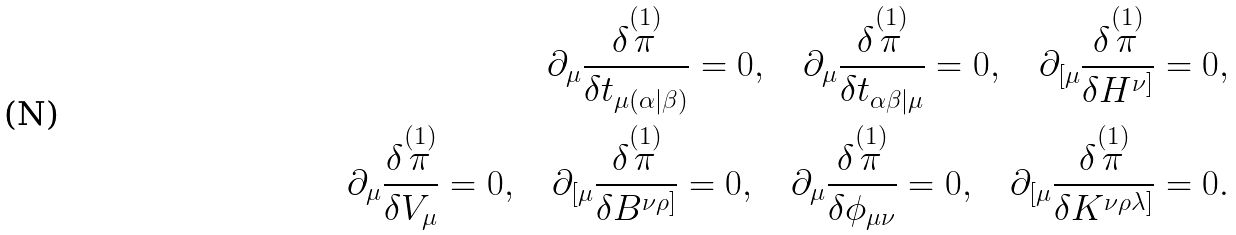<formula> <loc_0><loc_0><loc_500><loc_500>\partial _ { \mu } \frac { \delta \overset { ( 1 ) } { \pi } } { \delta t _ { \mu ( \alpha | \beta ) } } = 0 , \quad \partial _ { \mu } \frac { \delta \overset { ( 1 ) } { \pi } } { \delta t _ { \alpha \beta | \mu } } = 0 , \quad \partial _ { [ \mu } \frac { \delta \overset { ( 1 ) } { \pi } } { \delta H ^ { \nu ] } } = 0 , \\ \partial _ { \mu } \frac { \delta \overset { ( 1 ) } { \pi } } { \delta V _ { \mu } } = 0 , \quad \partial _ { [ \mu } \frac { \delta \overset { ( 1 ) } { \pi } } { \delta B ^ { \nu \rho ] } } = 0 , \quad \partial _ { \mu } \frac { \delta \overset { ( 1 ) } { \pi } } { \delta \phi _ { \mu \nu } } = 0 , \quad \partial _ { [ \mu } \frac { \delta \overset { ( 1 ) } { \pi } } { \delta K ^ { \nu \rho \lambda ] } } = 0 .</formula> 